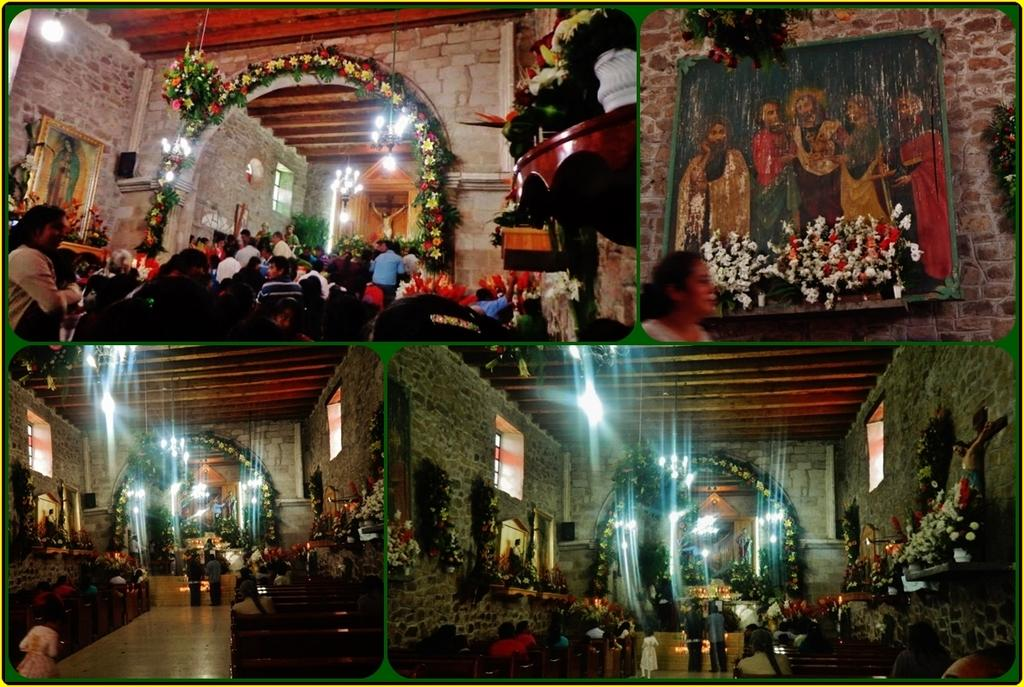What type of objects are present in the image that are related to flowers? There are flower bouquets and flower pots in the image. Can you describe the people in the image? There are people in the image, but their specific actions or appearances are not mentioned in the facts. What type of structures are present in the image? There are boards, lights, benches, windows, and a wall in the image. What type of mint can be seen growing near the flower pots in the image? There is no mention of mint in the image, so it cannot be determined if any mint is present. --- 